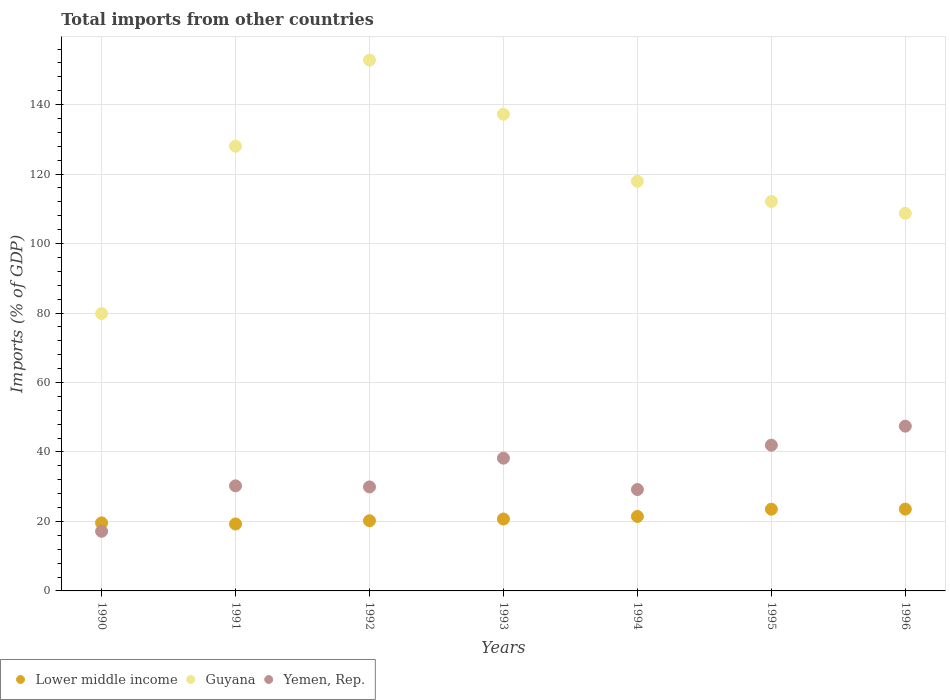What is the total imports in Guyana in 1993?
Keep it short and to the point. 137.23. Across all years, what is the maximum total imports in Lower middle income?
Your answer should be very brief. 23.55. Across all years, what is the minimum total imports in Guyana?
Your response must be concise. 79.86. In which year was the total imports in Guyana minimum?
Provide a succinct answer. 1990. What is the total total imports in Lower middle income in the graph?
Your answer should be very brief. 148.28. What is the difference between the total imports in Lower middle income in 1995 and that in 1996?
Provide a short and direct response. -0.02. What is the difference between the total imports in Guyana in 1993 and the total imports in Yemen, Rep. in 1994?
Ensure brevity in your answer.  108.04. What is the average total imports in Guyana per year?
Your answer should be very brief. 119.53. In the year 1995, what is the difference between the total imports in Guyana and total imports in Yemen, Rep.?
Provide a short and direct response. 70.16. What is the ratio of the total imports in Lower middle income in 1992 to that in 1996?
Ensure brevity in your answer.  0.86. What is the difference between the highest and the second highest total imports in Yemen, Rep.?
Your answer should be compact. 5.47. What is the difference between the highest and the lowest total imports in Guyana?
Your answer should be very brief. 72.95. Does the total imports in Lower middle income monotonically increase over the years?
Offer a very short reply. No. Is the total imports in Guyana strictly greater than the total imports in Lower middle income over the years?
Provide a succinct answer. Yes. Is the total imports in Lower middle income strictly less than the total imports in Guyana over the years?
Keep it short and to the point. Yes. How many years are there in the graph?
Your answer should be compact. 7. Does the graph contain any zero values?
Keep it short and to the point. No. Does the graph contain grids?
Make the answer very short. Yes. Where does the legend appear in the graph?
Offer a terse response. Bottom left. How many legend labels are there?
Provide a short and direct response. 3. How are the legend labels stacked?
Keep it short and to the point. Horizontal. What is the title of the graph?
Your answer should be very brief. Total imports from other countries. What is the label or title of the Y-axis?
Provide a succinct answer. Imports (% of GDP). What is the Imports (% of GDP) in Lower middle income in 1990?
Make the answer very short. 19.59. What is the Imports (% of GDP) of Guyana in 1990?
Provide a short and direct response. 79.86. What is the Imports (% of GDP) of Yemen, Rep. in 1990?
Offer a very short reply. 17.16. What is the Imports (% of GDP) of Lower middle income in 1991?
Your response must be concise. 19.27. What is the Imports (% of GDP) of Guyana in 1991?
Provide a short and direct response. 128.03. What is the Imports (% of GDP) in Yemen, Rep. in 1991?
Your response must be concise. 30.25. What is the Imports (% of GDP) of Lower middle income in 1992?
Your response must be concise. 20.21. What is the Imports (% of GDP) in Guyana in 1992?
Ensure brevity in your answer.  152.81. What is the Imports (% of GDP) in Yemen, Rep. in 1992?
Your answer should be compact. 29.94. What is the Imports (% of GDP) in Lower middle income in 1993?
Provide a succinct answer. 20.7. What is the Imports (% of GDP) of Guyana in 1993?
Ensure brevity in your answer.  137.23. What is the Imports (% of GDP) in Yemen, Rep. in 1993?
Offer a very short reply. 38.21. What is the Imports (% of GDP) of Lower middle income in 1994?
Provide a short and direct response. 21.44. What is the Imports (% of GDP) of Guyana in 1994?
Make the answer very short. 117.93. What is the Imports (% of GDP) of Yemen, Rep. in 1994?
Keep it short and to the point. 29.19. What is the Imports (% of GDP) of Lower middle income in 1995?
Keep it short and to the point. 23.53. What is the Imports (% of GDP) in Guyana in 1995?
Provide a short and direct response. 112.12. What is the Imports (% of GDP) of Yemen, Rep. in 1995?
Give a very brief answer. 41.96. What is the Imports (% of GDP) in Lower middle income in 1996?
Ensure brevity in your answer.  23.55. What is the Imports (% of GDP) of Guyana in 1996?
Keep it short and to the point. 108.72. What is the Imports (% of GDP) of Yemen, Rep. in 1996?
Ensure brevity in your answer.  47.43. Across all years, what is the maximum Imports (% of GDP) of Lower middle income?
Your response must be concise. 23.55. Across all years, what is the maximum Imports (% of GDP) of Guyana?
Offer a terse response. 152.81. Across all years, what is the maximum Imports (% of GDP) of Yemen, Rep.?
Offer a very short reply. 47.43. Across all years, what is the minimum Imports (% of GDP) in Lower middle income?
Make the answer very short. 19.27. Across all years, what is the minimum Imports (% of GDP) in Guyana?
Make the answer very short. 79.86. Across all years, what is the minimum Imports (% of GDP) in Yemen, Rep.?
Offer a terse response. 17.16. What is the total Imports (% of GDP) in Lower middle income in the graph?
Offer a terse response. 148.28. What is the total Imports (% of GDP) of Guyana in the graph?
Keep it short and to the point. 836.69. What is the total Imports (% of GDP) in Yemen, Rep. in the graph?
Provide a succinct answer. 234.14. What is the difference between the Imports (% of GDP) of Lower middle income in 1990 and that in 1991?
Offer a very short reply. 0.32. What is the difference between the Imports (% of GDP) of Guyana in 1990 and that in 1991?
Make the answer very short. -48.17. What is the difference between the Imports (% of GDP) in Yemen, Rep. in 1990 and that in 1991?
Give a very brief answer. -13.09. What is the difference between the Imports (% of GDP) of Lower middle income in 1990 and that in 1992?
Provide a short and direct response. -0.62. What is the difference between the Imports (% of GDP) of Guyana in 1990 and that in 1992?
Keep it short and to the point. -72.95. What is the difference between the Imports (% of GDP) in Yemen, Rep. in 1990 and that in 1992?
Your answer should be compact. -12.78. What is the difference between the Imports (% of GDP) in Lower middle income in 1990 and that in 1993?
Provide a short and direct response. -1.11. What is the difference between the Imports (% of GDP) of Guyana in 1990 and that in 1993?
Give a very brief answer. -57.37. What is the difference between the Imports (% of GDP) in Yemen, Rep. in 1990 and that in 1993?
Offer a very short reply. -21.05. What is the difference between the Imports (% of GDP) in Lower middle income in 1990 and that in 1994?
Provide a short and direct response. -1.85. What is the difference between the Imports (% of GDP) in Guyana in 1990 and that in 1994?
Offer a very short reply. -38.07. What is the difference between the Imports (% of GDP) in Yemen, Rep. in 1990 and that in 1994?
Offer a very short reply. -12.02. What is the difference between the Imports (% of GDP) of Lower middle income in 1990 and that in 1995?
Make the answer very short. -3.94. What is the difference between the Imports (% of GDP) of Guyana in 1990 and that in 1995?
Give a very brief answer. -32.26. What is the difference between the Imports (% of GDP) in Yemen, Rep. in 1990 and that in 1995?
Ensure brevity in your answer.  -24.8. What is the difference between the Imports (% of GDP) in Lower middle income in 1990 and that in 1996?
Provide a short and direct response. -3.96. What is the difference between the Imports (% of GDP) of Guyana in 1990 and that in 1996?
Your response must be concise. -28.86. What is the difference between the Imports (% of GDP) of Yemen, Rep. in 1990 and that in 1996?
Provide a succinct answer. -30.27. What is the difference between the Imports (% of GDP) in Lower middle income in 1991 and that in 1992?
Provide a short and direct response. -0.94. What is the difference between the Imports (% of GDP) of Guyana in 1991 and that in 1992?
Give a very brief answer. -24.77. What is the difference between the Imports (% of GDP) in Yemen, Rep. in 1991 and that in 1992?
Your answer should be compact. 0.31. What is the difference between the Imports (% of GDP) in Lower middle income in 1991 and that in 1993?
Your answer should be compact. -1.44. What is the difference between the Imports (% of GDP) of Guyana in 1991 and that in 1993?
Give a very brief answer. -9.19. What is the difference between the Imports (% of GDP) in Yemen, Rep. in 1991 and that in 1993?
Provide a short and direct response. -7.97. What is the difference between the Imports (% of GDP) of Lower middle income in 1991 and that in 1994?
Your answer should be compact. -2.17. What is the difference between the Imports (% of GDP) in Guyana in 1991 and that in 1994?
Make the answer very short. 10.1. What is the difference between the Imports (% of GDP) in Yemen, Rep. in 1991 and that in 1994?
Your answer should be compact. 1.06. What is the difference between the Imports (% of GDP) of Lower middle income in 1991 and that in 1995?
Offer a very short reply. -4.26. What is the difference between the Imports (% of GDP) of Guyana in 1991 and that in 1995?
Provide a succinct answer. 15.92. What is the difference between the Imports (% of GDP) of Yemen, Rep. in 1991 and that in 1995?
Offer a very short reply. -11.71. What is the difference between the Imports (% of GDP) in Lower middle income in 1991 and that in 1996?
Your response must be concise. -4.28. What is the difference between the Imports (% of GDP) in Guyana in 1991 and that in 1996?
Give a very brief answer. 19.32. What is the difference between the Imports (% of GDP) in Yemen, Rep. in 1991 and that in 1996?
Offer a very short reply. -17.19. What is the difference between the Imports (% of GDP) of Lower middle income in 1992 and that in 1993?
Give a very brief answer. -0.49. What is the difference between the Imports (% of GDP) of Guyana in 1992 and that in 1993?
Your answer should be compact. 15.58. What is the difference between the Imports (% of GDP) in Yemen, Rep. in 1992 and that in 1993?
Your answer should be very brief. -8.28. What is the difference between the Imports (% of GDP) of Lower middle income in 1992 and that in 1994?
Your answer should be compact. -1.23. What is the difference between the Imports (% of GDP) in Guyana in 1992 and that in 1994?
Your answer should be very brief. 34.88. What is the difference between the Imports (% of GDP) in Yemen, Rep. in 1992 and that in 1994?
Your answer should be compact. 0.75. What is the difference between the Imports (% of GDP) in Lower middle income in 1992 and that in 1995?
Your response must be concise. -3.32. What is the difference between the Imports (% of GDP) in Guyana in 1992 and that in 1995?
Provide a short and direct response. 40.69. What is the difference between the Imports (% of GDP) in Yemen, Rep. in 1992 and that in 1995?
Provide a succinct answer. -12.02. What is the difference between the Imports (% of GDP) of Lower middle income in 1992 and that in 1996?
Your answer should be compact. -3.34. What is the difference between the Imports (% of GDP) in Guyana in 1992 and that in 1996?
Your response must be concise. 44.09. What is the difference between the Imports (% of GDP) in Yemen, Rep. in 1992 and that in 1996?
Ensure brevity in your answer.  -17.49. What is the difference between the Imports (% of GDP) of Lower middle income in 1993 and that in 1994?
Make the answer very short. -0.73. What is the difference between the Imports (% of GDP) of Guyana in 1993 and that in 1994?
Provide a short and direct response. 19.3. What is the difference between the Imports (% of GDP) in Yemen, Rep. in 1993 and that in 1994?
Make the answer very short. 9.03. What is the difference between the Imports (% of GDP) in Lower middle income in 1993 and that in 1995?
Offer a very short reply. -2.82. What is the difference between the Imports (% of GDP) of Guyana in 1993 and that in 1995?
Your response must be concise. 25.11. What is the difference between the Imports (% of GDP) in Yemen, Rep. in 1993 and that in 1995?
Make the answer very short. -3.74. What is the difference between the Imports (% of GDP) in Lower middle income in 1993 and that in 1996?
Your answer should be compact. -2.85. What is the difference between the Imports (% of GDP) of Guyana in 1993 and that in 1996?
Your answer should be compact. 28.51. What is the difference between the Imports (% of GDP) in Yemen, Rep. in 1993 and that in 1996?
Make the answer very short. -9.22. What is the difference between the Imports (% of GDP) in Lower middle income in 1994 and that in 1995?
Your answer should be very brief. -2.09. What is the difference between the Imports (% of GDP) of Guyana in 1994 and that in 1995?
Offer a very short reply. 5.81. What is the difference between the Imports (% of GDP) in Yemen, Rep. in 1994 and that in 1995?
Give a very brief answer. -12.77. What is the difference between the Imports (% of GDP) of Lower middle income in 1994 and that in 1996?
Your response must be concise. -2.11. What is the difference between the Imports (% of GDP) in Guyana in 1994 and that in 1996?
Keep it short and to the point. 9.21. What is the difference between the Imports (% of GDP) in Yemen, Rep. in 1994 and that in 1996?
Your answer should be compact. -18.25. What is the difference between the Imports (% of GDP) of Lower middle income in 1995 and that in 1996?
Ensure brevity in your answer.  -0.02. What is the difference between the Imports (% of GDP) in Guyana in 1995 and that in 1996?
Give a very brief answer. 3.4. What is the difference between the Imports (% of GDP) in Yemen, Rep. in 1995 and that in 1996?
Offer a very short reply. -5.47. What is the difference between the Imports (% of GDP) of Lower middle income in 1990 and the Imports (% of GDP) of Guyana in 1991?
Offer a very short reply. -108.44. What is the difference between the Imports (% of GDP) in Lower middle income in 1990 and the Imports (% of GDP) in Yemen, Rep. in 1991?
Offer a terse response. -10.66. What is the difference between the Imports (% of GDP) of Guyana in 1990 and the Imports (% of GDP) of Yemen, Rep. in 1991?
Give a very brief answer. 49.61. What is the difference between the Imports (% of GDP) of Lower middle income in 1990 and the Imports (% of GDP) of Guyana in 1992?
Make the answer very short. -133.22. What is the difference between the Imports (% of GDP) in Lower middle income in 1990 and the Imports (% of GDP) in Yemen, Rep. in 1992?
Make the answer very short. -10.35. What is the difference between the Imports (% of GDP) of Guyana in 1990 and the Imports (% of GDP) of Yemen, Rep. in 1992?
Your response must be concise. 49.92. What is the difference between the Imports (% of GDP) of Lower middle income in 1990 and the Imports (% of GDP) of Guyana in 1993?
Ensure brevity in your answer.  -117.64. What is the difference between the Imports (% of GDP) of Lower middle income in 1990 and the Imports (% of GDP) of Yemen, Rep. in 1993?
Offer a very short reply. -18.62. What is the difference between the Imports (% of GDP) of Guyana in 1990 and the Imports (% of GDP) of Yemen, Rep. in 1993?
Give a very brief answer. 41.65. What is the difference between the Imports (% of GDP) of Lower middle income in 1990 and the Imports (% of GDP) of Guyana in 1994?
Your answer should be very brief. -98.34. What is the difference between the Imports (% of GDP) of Lower middle income in 1990 and the Imports (% of GDP) of Yemen, Rep. in 1994?
Your answer should be very brief. -9.6. What is the difference between the Imports (% of GDP) in Guyana in 1990 and the Imports (% of GDP) in Yemen, Rep. in 1994?
Make the answer very short. 50.67. What is the difference between the Imports (% of GDP) in Lower middle income in 1990 and the Imports (% of GDP) in Guyana in 1995?
Make the answer very short. -92.53. What is the difference between the Imports (% of GDP) of Lower middle income in 1990 and the Imports (% of GDP) of Yemen, Rep. in 1995?
Your response must be concise. -22.37. What is the difference between the Imports (% of GDP) in Guyana in 1990 and the Imports (% of GDP) in Yemen, Rep. in 1995?
Your answer should be compact. 37.9. What is the difference between the Imports (% of GDP) in Lower middle income in 1990 and the Imports (% of GDP) in Guyana in 1996?
Provide a short and direct response. -89.13. What is the difference between the Imports (% of GDP) in Lower middle income in 1990 and the Imports (% of GDP) in Yemen, Rep. in 1996?
Ensure brevity in your answer.  -27.84. What is the difference between the Imports (% of GDP) of Guyana in 1990 and the Imports (% of GDP) of Yemen, Rep. in 1996?
Offer a very short reply. 32.43. What is the difference between the Imports (% of GDP) of Lower middle income in 1991 and the Imports (% of GDP) of Guyana in 1992?
Offer a terse response. -133.54. What is the difference between the Imports (% of GDP) of Lower middle income in 1991 and the Imports (% of GDP) of Yemen, Rep. in 1992?
Your answer should be very brief. -10.67. What is the difference between the Imports (% of GDP) of Guyana in 1991 and the Imports (% of GDP) of Yemen, Rep. in 1992?
Offer a very short reply. 98.1. What is the difference between the Imports (% of GDP) of Lower middle income in 1991 and the Imports (% of GDP) of Guyana in 1993?
Provide a succinct answer. -117.96. What is the difference between the Imports (% of GDP) of Lower middle income in 1991 and the Imports (% of GDP) of Yemen, Rep. in 1993?
Offer a terse response. -18.95. What is the difference between the Imports (% of GDP) in Guyana in 1991 and the Imports (% of GDP) in Yemen, Rep. in 1993?
Provide a succinct answer. 89.82. What is the difference between the Imports (% of GDP) of Lower middle income in 1991 and the Imports (% of GDP) of Guyana in 1994?
Make the answer very short. -98.66. What is the difference between the Imports (% of GDP) of Lower middle income in 1991 and the Imports (% of GDP) of Yemen, Rep. in 1994?
Give a very brief answer. -9.92. What is the difference between the Imports (% of GDP) of Guyana in 1991 and the Imports (% of GDP) of Yemen, Rep. in 1994?
Your answer should be compact. 98.85. What is the difference between the Imports (% of GDP) of Lower middle income in 1991 and the Imports (% of GDP) of Guyana in 1995?
Offer a terse response. -92.85. What is the difference between the Imports (% of GDP) of Lower middle income in 1991 and the Imports (% of GDP) of Yemen, Rep. in 1995?
Provide a short and direct response. -22.69. What is the difference between the Imports (% of GDP) of Guyana in 1991 and the Imports (% of GDP) of Yemen, Rep. in 1995?
Your answer should be compact. 86.08. What is the difference between the Imports (% of GDP) in Lower middle income in 1991 and the Imports (% of GDP) in Guyana in 1996?
Make the answer very short. -89.45. What is the difference between the Imports (% of GDP) in Lower middle income in 1991 and the Imports (% of GDP) in Yemen, Rep. in 1996?
Keep it short and to the point. -28.17. What is the difference between the Imports (% of GDP) in Guyana in 1991 and the Imports (% of GDP) in Yemen, Rep. in 1996?
Your response must be concise. 80.6. What is the difference between the Imports (% of GDP) of Lower middle income in 1992 and the Imports (% of GDP) of Guyana in 1993?
Offer a very short reply. -117.02. What is the difference between the Imports (% of GDP) in Lower middle income in 1992 and the Imports (% of GDP) in Yemen, Rep. in 1993?
Ensure brevity in your answer.  -18. What is the difference between the Imports (% of GDP) in Guyana in 1992 and the Imports (% of GDP) in Yemen, Rep. in 1993?
Ensure brevity in your answer.  114.59. What is the difference between the Imports (% of GDP) in Lower middle income in 1992 and the Imports (% of GDP) in Guyana in 1994?
Offer a terse response. -97.72. What is the difference between the Imports (% of GDP) in Lower middle income in 1992 and the Imports (% of GDP) in Yemen, Rep. in 1994?
Give a very brief answer. -8.98. What is the difference between the Imports (% of GDP) of Guyana in 1992 and the Imports (% of GDP) of Yemen, Rep. in 1994?
Keep it short and to the point. 123.62. What is the difference between the Imports (% of GDP) of Lower middle income in 1992 and the Imports (% of GDP) of Guyana in 1995?
Offer a terse response. -91.91. What is the difference between the Imports (% of GDP) of Lower middle income in 1992 and the Imports (% of GDP) of Yemen, Rep. in 1995?
Provide a short and direct response. -21.75. What is the difference between the Imports (% of GDP) in Guyana in 1992 and the Imports (% of GDP) in Yemen, Rep. in 1995?
Keep it short and to the point. 110.85. What is the difference between the Imports (% of GDP) of Lower middle income in 1992 and the Imports (% of GDP) of Guyana in 1996?
Ensure brevity in your answer.  -88.51. What is the difference between the Imports (% of GDP) of Lower middle income in 1992 and the Imports (% of GDP) of Yemen, Rep. in 1996?
Your response must be concise. -27.22. What is the difference between the Imports (% of GDP) in Guyana in 1992 and the Imports (% of GDP) in Yemen, Rep. in 1996?
Provide a short and direct response. 105.37. What is the difference between the Imports (% of GDP) in Lower middle income in 1993 and the Imports (% of GDP) in Guyana in 1994?
Offer a very short reply. -97.23. What is the difference between the Imports (% of GDP) of Lower middle income in 1993 and the Imports (% of GDP) of Yemen, Rep. in 1994?
Your answer should be very brief. -8.48. What is the difference between the Imports (% of GDP) in Guyana in 1993 and the Imports (% of GDP) in Yemen, Rep. in 1994?
Provide a succinct answer. 108.04. What is the difference between the Imports (% of GDP) in Lower middle income in 1993 and the Imports (% of GDP) in Guyana in 1995?
Your answer should be very brief. -91.41. What is the difference between the Imports (% of GDP) in Lower middle income in 1993 and the Imports (% of GDP) in Yemen, Rep. in 1995?
Give a very brief answer. -21.26. What is the difference between the Imports (% of GDP) of Guyana in 1993 and the Imports (% of GDP) of Yemen, Rep. in 1995?
Your answer should be very brief. 95.27. What is the difference between the Imports (% of GDP) in Lower middle income in 1993 and the Imports (% of GDP) in Guyana in 1996?
Make the answer very short. -88.01. What is the difference between the Imports (% of GDP) in Lower middle income in 1993 and the Imports (% of GDP) in Yemen, Rep. in 1996?
Provide a short and direct response. -26.73. What is the difference between the Imports (% of GDP) of Guyana in 1993 and the Imports (% of GDP) of Yemen, Rep. in 1996?
Make the answer very short. 89.79. What is the difference between the Imports (% of GDP) in Lower middle income in 1994 and the Imports (% of GDP) in Guyana in 1995?
Ensure brevity in your answer.  -90.68. What is the difference between the Imports (% of GDP) in Lower middle income in 1994 and the Imports (% of GDP) in Yemen, Rep. in 1995?
Keep it short and to the point. -20.52. What is the difference between the Imports (% of GDP) of Guyana in 1994 and the Imports (% of GDP) of Yemen, Rep. in 1995?
Ensure brevity in your answer.  75.97. What is the difference between the Imports (% of GDP) in Lower middle income in 1994 and the Imports (% of GDP) in Guyana in 1996?
Offer a terse response. -87.28. What is the difference between the Imports (% of GDP) in Lower middle income in 1994 and the Imports (% of GDP) in Yemen, Rep. in 1996?
Ensure brevity in your answer.  -26. What is the difference between the Imports (% of GDP) of Guyana in 1994 and the Imports (% of GDP) of Yemen, Rep. in 1996?
Your answer should be compact. 70.5. What is the difference between the Imports (% of GDP) in Lower middle income in 1995 and the Imports (% of GDP) in Guyana in 1996?
Your answer should be very brief. -85.19. What is the difference between the Imports (% of GDP) of Lower middle income in 1995 and the Imports (% of GDP) of Yemen, Rep. in 1996?
Your answer should be very brief. -23.91. What is the difference between the Imports (% of GDP) in Guyana in 1995 and the Imports (% of GDP) in Yemen, Rep. in 1996?
Make the answer very short. 64.68. What is the average Imports (% of GDP) of Lower middle income per year?
Your answer should be very brief. 21.18. What is the average Imports (% of GDP) in Guyana per year?
Give a very brief answer. 119.53. What is the average Imports (% of GDP) of Yemen, Rep. per year?
Ensure brevity in your answer.  33.45. In the year 1990, what is the difference between the Imports (% of GDP) in Lower middle income and Imports (% of GDP) in Guyana?
Offer a very short reply. -60.27. In the year 1990, what is the difference between the Imports (% of GDP) of Lower middle income and Imports (% of GDP) of Yemen, Rep.?
Offer a terse response. 2.43. In the year 1990, what is the difference between the Imports (% of GDP) in Guyana and Imports (% of GDP) in Yemen, Rep.?
Give a very brief answer. 62.7. In the year 1991, what is the difference between the Imports (% of GDP) of Lower middle income and Imports (% of GDP) of Guyana?
Give a very brief answer. -108.77. In the year 1991, what is the difference between the Imports (% of GDP) of Lower middle income and Imports (% of GDP) of Yemen, Rep.?
Provide a succinct answer. -10.98. In the year 1991, what is the difference between the Imports (% of GDP) in Guyana and Imports (% of GDP) in Yemen, Rep.?
Your answer should be compact. 97.79. In the year 1992, what is the difference between the Imports (% of GDP) of Lower middle income and Imports (% of GDP) of Guyana?
Offer a terse response. -132.6. In the year 1992, what is the difference between the Imports (% of GDP) in Lower middle income and Imports (% of GDP) in Yemen, Rep.?
Your answer should be compact. -9.73. In the year 1992, what is the difference between the Imports (% of GDP) in Guyana and Imports (% of GDP) in Yemen, Rep.?
Offer a terse response. 122.87. In the year 1993, what is the difference between the Imports (% of GDP) in Lower middle income and Imports (% of GDP) in Guyana?
Ensure brevity in your answer.  -116.52. In the year 1993, what is the difference between the Imports (% of GDP) in Lower middle income and Imports (% of GDP) in Yemen, Rep.?
Your response must be concise. -17.51. In the year 1993, what is the difference between the Imports (% of GDP) of Guyana and Imports (% of GDP) of Yemen, Rep.?
Your response must be concise. 99.01. In the year 1994, what is the difference between the Imports (% of GDP) in Lower middle income and Imports (% of GDP) in Guyana?
Offer a very short reply. -96.49. In the year 1994, what is the difference between the Imports (% of GDP) of Lower middle income and Imports (% of GDP) of Yemen, Rep.?
Provide a succinct answer. -7.75. In the year 1994, what is the difference between the Imports (% of GDP) of Guyana and Imports (% of GDP) of Yemen, Rep.?
Provide a short and direct response. 88.74. In the year 1995, what is the difference between the Imports (% of GDP) in Lower middle income and Imports (% of GDP) in Guyana?
Make the answer very short. -88.59. In the year 1995, what is the difference between the Imports (% of GDP) in Lower middle income and Imports (% of GDP) in Yemen, Rep.?
Offer a terse response. -18.43. In the year 1995, what is the difference between the Imports (% of GDP) in Guyana and Imports (% of GDP) in Yemen, Rep.?
Give a very brief answer. 70.16. In the year 1996, what is the difference between the Imports (% of GDP) in Lower middle income and Imports (% of GDP) in Guyana?
Your response must be concise. -85.17. In the year 1996, what is the difference between the Imports (% of GDP) of Lower middle income and Imports (% of GDP) of Yemen, Rep.?
Make the answer very short. -23.88. In the year 1996, what is the difference between the Imports (% of GDP) in Guyana and Imports (% of GDP) in Yemen, Rep.?
Your answer should be very brief. 61.28. What is the ratio of the Imports (% of GDP) in Lower middle income in 1990 to that in 1991?
Make the answer very short. 1.02. What is the ratio of the Imports (% of GDP) of Guyana in 1990 to that in 1991?
Make the answer very short. 0.62. What is the ratio of the Imports (% of GDP) of Yemen, Rep. in 1990 to that in 1991?
Provide a short and direct response. 0.57. What is the ratio of the Imports (% of GDP) of Lower middle income in 1990 to that in 1992?
Provide a short and direct response. 0.97. What is the ratio of the Imports (% of GDP) in Guyana in 1990 to that in 1992?
Make the answer very short. 0.52. What is the ratio of the Imports (% of GDP) in Yemen, Rep. in 1990 to that in 1992?
Provide a short and direct response. 0.57. What is the ratio of the Imports (% of GDP) of Lower middle income in 1990 to that in 1993?
Make the answer very short. 0.95. What is the ratio of the Imports (% of GDP) in Guyana in 1990 to that in 1993?
Provide a short and direct response. 0.58. What is the ratio of the Imports (% of GDP) in Yemen, Rep. in 1990 to that in 1993?
Keep it short and to the point. 0.45. What is the ratio of the Imports (% of GDP) of Lower middle income in 1990 to that in 1994?
Ensure brevity in your answer.  0.91. What is the ratio of the Imports (% of GDP) in Guyana in 1990 to that in 1994?
Ensure brevity in your answer.  0.68. What is the ratio of the Imports (% of GDP) of Yemen, Rep. in 1990 to that in 1994?
Your response must be concise. 0.59. What is the ratio of the Imports (% of GDP) in Lower middle income in 1990 to that in 1995?
Give a very brief answer. 0.83. What is the ratio of the Imports (% of GDP) in Guyana in 1990 to that in 1995?
Make the answer very short. 0.71. What is the ratio of the Imports (% of GDP) of Yemen, Rep. in 1990 to that in 1995?
Make the answer very short. 0.41. What is the ratio of the Imports (% of GDP) in Lower middle income in 1990 to that in 1996?
Make the answer very short. 0.83. What is the ratio of the Imports (% of GDP) in Guyana in 1990 to that in 1996?
Your response must be concise. 0.73. What is the ratio of the Imports (% of GDP) in Yemen, Rep. in 1990 to that in 1996?
Keep it short and to the point. 0.36. What is the ratio of the Imports (% of GDP) of Lower middle income in 1991 to that in 1992?
Give a very brief answer. 0.95. What is the ratio of the Imports (% of GDP) in Guyana in 1991 to that in 1992?
Your answer should be compact. 0.84. What is the ratio of the Imports (% of GDP) in Yemen, Rep. in 1991 to that in 1992?
Your answer should be very brief. 1.01. What is the ratio of the Imports (% of GDP) of Lower middle income in 1991 to that in 1993?
Make the answer very short. 0.93. What is the ratio of the Imports (% of GDP) of Guyana in 1991 to that in 1993?
Offer a very short reply. 0.93. What is the ratio of the Imports (% of GDP) of Yemen, Rep. in 1991 to that in 1993?
Provide a succinct answer. 0.79. What is the ratio of the Imports (% of GDP) in Lower middle income in 1991 to that in 1994?
Your answer should be very brief. 0.9. What is the ratio of the Imports (% of GDP) of Guyana in 1991 to that in 1994?
Provide a succinct answer. 1.09. What is the ratio of the Imports (% of GDP) in Yemen, Rep. in 1991 to that in 1994?
Offer a very short reply. 1.04. What is the ratio of the Imports (% of GDP) of Lower middle income in 1991 to that in 1995?
Offer a terse response. 0.82. What is the ratio of the Imports (% of GDP) in Guyana in 1991 to that in 1995?
Ensure brevity in your answer.  1.14. What is the ratio of the Imports (% of GDP) in Yemen, Rep. in 1991 to that in 1995?
Offer a terse response. 0.72. What is the ratio of the Imports (% of GDP) in Lower middle income in 1991 to that in 1996?
Your response must be concise. 0.82. What is the ratio of the Imports (% of GDP) in Guyana in 1991 to that in 1996?
Give a very brief answer. 1.18. What is the ratio of the Imports (% of GDP) in Yemen, Rep. in 1991 to that in 1996?
Provide a short and direct response. 0.64. What is the ratio of the Imports (% of GDP) of Lower middle income in 1992 to that in 1993?
Ensure brevity in your answer.  0.98. What is the ratio of the Imports (% of GDP) of Guyana in 1992 to that in 1993?
Provide a short and direct response. 1.11. What is the ratio of the Imports (% of GDP) in Yemen, Rep. in 1992 to that in 1993?
Ensure brevity in your answer.  0.78. What is the ratio of the Imports (% of GDP) in Lower middle income in 1992 to that in 1994?
Provide a succinct answer. 0.94. What is the ratio of the Imports (% of GDP) of Guyana in 1992 to that in 1994?
Keep it short and to the point. 1.3. What is the ratio of the Imports (% of GDP) of Yemen, Rep. in 1992 to that in 1994?
Offer a terse response. 1.03. What is the ratio of the Imports (% of GDP) of Lower middle income in 1992 to that in 1995?
Ensure brevity in your answer.  0.86. What is the ratio of the Imports (% of GDP) of Guyana in 1992 to that in 1995?
Keep it short and to the point. 1.36. What is the ratio of the Imports (% of GDP) in Yemen, Rep. in 1992 to that in 1995?
Ensure brevity in your answer.  0.71. What is the ratio of the Imports (% of GDP) in Lower middle income in 1992 to that in 1996?
Make the answer very short. 0.86. What is the ratio of the Imports (% of GDP) in Guyana in 1992 to that in 1996?
Provide a short and direct response. 1.41. What is the ratio of the Imports (% of GDP) of Yemen, Rep. in 1992 to that in 1996?
Make the answer very short. 0.63. What is the ratio of the Imports (% of GDP) of Lower middle income in 1993 to that in 1994?
Your response must be concise. 0.97. What is the ratio of the Imports (% of GDP) of Guyana in 1993 to that in 1994?
Your answer should be very brief. 1.16. What is the ratio of the Imports (% of GDP) in Yemen, Rep. in 1993 to that in 1994?
Keep it short and to the point. 1.31. What is the ratio of the Imports (% of GDP) in Lower middle income in 1993 to that in 1995?
Keep it short and to the point. 0.88. What is the ratio of the Imports (% of GDP) of Guyana in 1993 to that in 1995?
Your answer should be very brief. 1.22. What is the ratio of the Imports (% of GDP) in Yemen, Rep. in 1993 to that in 1995?
Your response must be concise. 0.91. What is the ratio of the Imports (% of GDP) in Lower middle income in 1993 to that in 1996?
Provide a succinct answer. 0.88. What is the ratio of the Imports (% of GDP) of Guyana in 1993 to that in 1996?
Keep it short and to the point. 1.26. What is the ratio of the Imports (% of GDP) of Yemen, Rep. in 1993 to that in 1996?
Keep it short and to the point. 0.81. What is the ratio of the Imports (% of GDP) of Lower middle income in 1994 to that in 1995?
Give a very brief answer. 0.91. What is the ratio of the Imports (% of GDP) in Guyana in 1994 to that in 1995?
Provide a succinct answer. 1.05. What is the ratio of the Imports (% of GDP) of Yemen, Rep. in 1994 to that in 1995?
Offer a very short reply. 0.7. What is the ratio of the Imports (% of GDP) of Lower middle income in 1994 to that in 1996?
Your answer should be very brief. 0.91. What is the ratio of the Imports (% of GDP) of Guyana in 1994 to that in 1996?
Give a very brief answer. 1.08. What is the ratio of the Imports (% of GDP) of Yemen, Rep. in 1994 to that in 1996?
Ensure brevity in your answer.  0.62. What is the ratio of the Imports (% of GDP) of Lower middle income in 1995 to that in 1996?
Offer a very short reply. 1. What is the ratio of the Imports (% of GDP) in Guyana in 1995 to that in 1996?
Ensure brevity in your answer.  1.03. What is the ratio of the Imports (% of GDP) in Yemen, Rep. in 1995 to that in 1996?
Give a very brief answer. 0.88. What is the difference between the highest and the second highest Imports (% of GDP) in Lower middle income?
Offer a terse response. 0.02. What is the difference between the highest and the second highest Imports (% of GDP) of Guyana?
Give a very brief answer. 15.58. What is the difference between the highest and the second highest Imports (% of GDP) in Yemen, Rep.?
Make the answer very short. 5.47. What is the difference between the highest and the lowest Imports (% of GDP) in Lower middle income?
Offer a very short reply. 4.28. What is the difference between the highest and the lowest Imports (% of GDP) in Guyana?
Your answer should be very brief. 72.95. What is the difference between the highest and the lowest Imports (% of GDP) in Yemen, Rep.?
Keep it short and to the point. 30.27. 